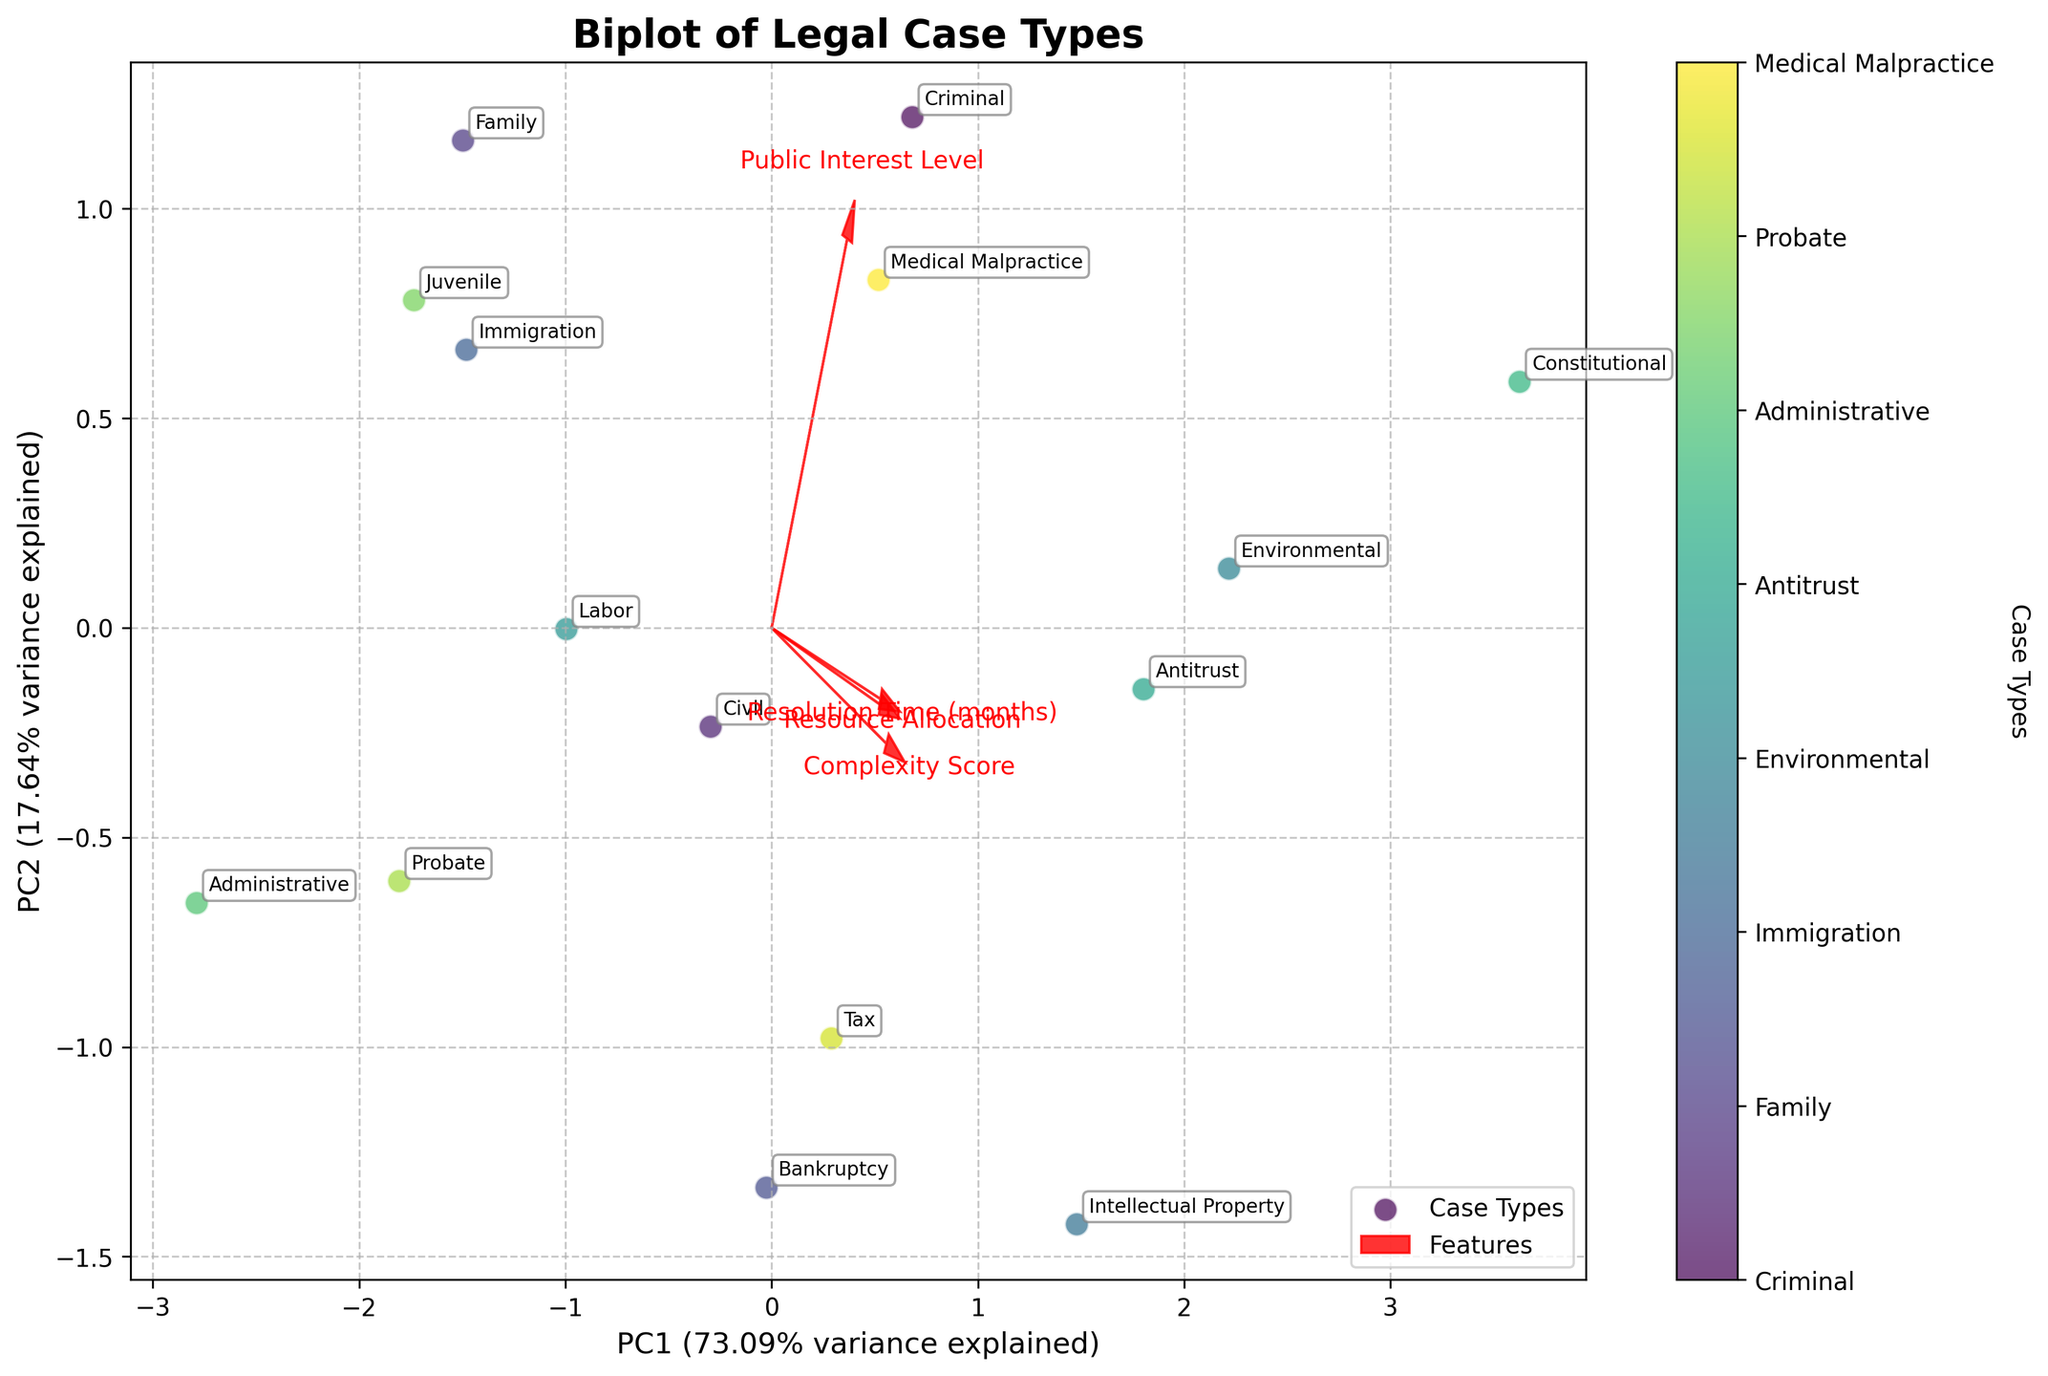What is the title of the plot? The title is typically located at the top of the plot and provides a summary of what the plot represents
Answer: Biplot of Legal Case Types How many axes are there in the plot, and what do they represent? Observing the plot shows two axes, the horizontal axis represents PC1, and the vertical axis represents PC2.
Answer: 2 axes, PC1 and PC2 Which case type is located furthest to the right on the plot? Identifying the rightmost point involves looking at the x-coordinates of all case types, where "Constitutional" has the highest x-coordinate.
Answer: Constitutional What does the axis label "PC1" indicate about variance? The label "PC1" shows the variance explained by the first principal component, calculated from the explained variance ratio.
Answer: % of variance explained by PC1 Which feature vector seems to have the strongest influence on PC2? Examining the length and direction of arrows along the PC2 (y-axis) indicates that "Public Interest Level" has the largest contribution to PC2.
Answer: Public Interest Level Which case types have similar resolution times based on their proximity on the plot? Case types that are close to each other on the plot represent similar resolution times. For example, "Juvenile" and "Family" are near each other.
Answer: Juvenile and Family How is 'Complexity Score' represented in the biplot, and what does its arrow direction suggest? The 'Complexity Score' is shown by an arrow, and its direction from the origin suggests a positive correlation with increasing values along the PC1 axis.
Answer: Positive correlation with PC1 Which two case types are closest to each other on the biplot? By observing the proximity of points, "Civil" and "Labor" are found to be the closest to each other.
Answer: Civil and Labor Is 'Resource Allocation' positively or negatively correlated with 'Resolution Time (months)'? The angle between arrows representing these features is acute, thus indicating a positive correlation.
Answer: Positively correlated Which case type shows the highest level of public interest as seen in the plot? The case type located farthest in the direction of the 'Public Interest Level' vector is "Constitutional".
Answer: Constitutional 